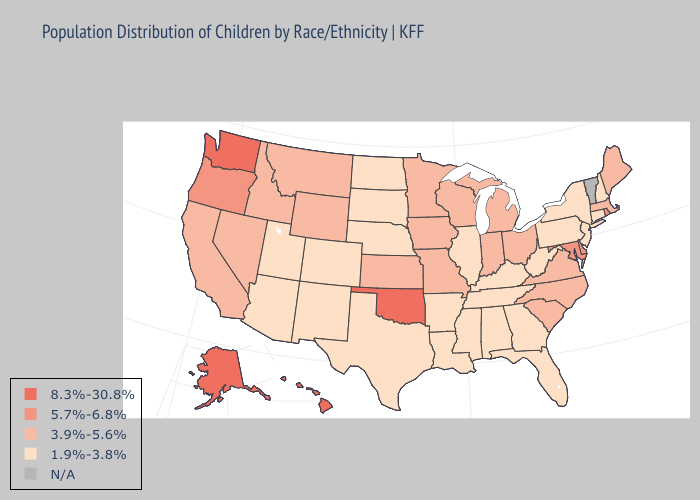What is the highest value in the West ?
Short answer required. 8.3%-30.8%. Name the states that have a value in the range N/A?
Be succinct. Vermont. What is the value of Wisconsin?
Quick response, please. 3.9%-5.6%. Name the states that have a value in the range 3.9%-5.6%?
Answer briefly. California, Idaho, Indiana, Iowa, Kansas, Maine, Massachusetts, Michigan, Minnesota, Missouri, Montana, Nevada, North Carolina, Ohio, South Carolina, Virginia, Wisconsin, Wyoming. What is the highest value in the South ?
Keep it brief. 8.3%-30.8%. What is the lowest value in the South?
Short answer required. 1.9%-3.8%. Which states hav the highest value in the Northeast?
Short answer required. Rhode Island. Does Nevada have the highest value in the West?
Give a very brief answer. No. Does Hawaii have the highest value in the USA?
Short answer required. Yes. Among the states that border Arkansas , which have the highest value?
Write a very short answer. Oklahoma. Name the states that have a value in the range N/A?
Keep it brief. Vermont. Name the states that have a value in the range N/A?
Be succinct. Vermont. Is the legend a continuous bar?
Concise answer only. No. 